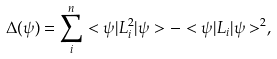Convert formula to latex. <formula><loc_0><loc_0><loc_500><loc_500>\Delta ( \psi ) = \sum _ { i } ^ { n } < \psi | L _ { i } ^ { 2 } | \psi > - < \psi | L _ { i } | \psi > ^ { 2 } ,</formula> 